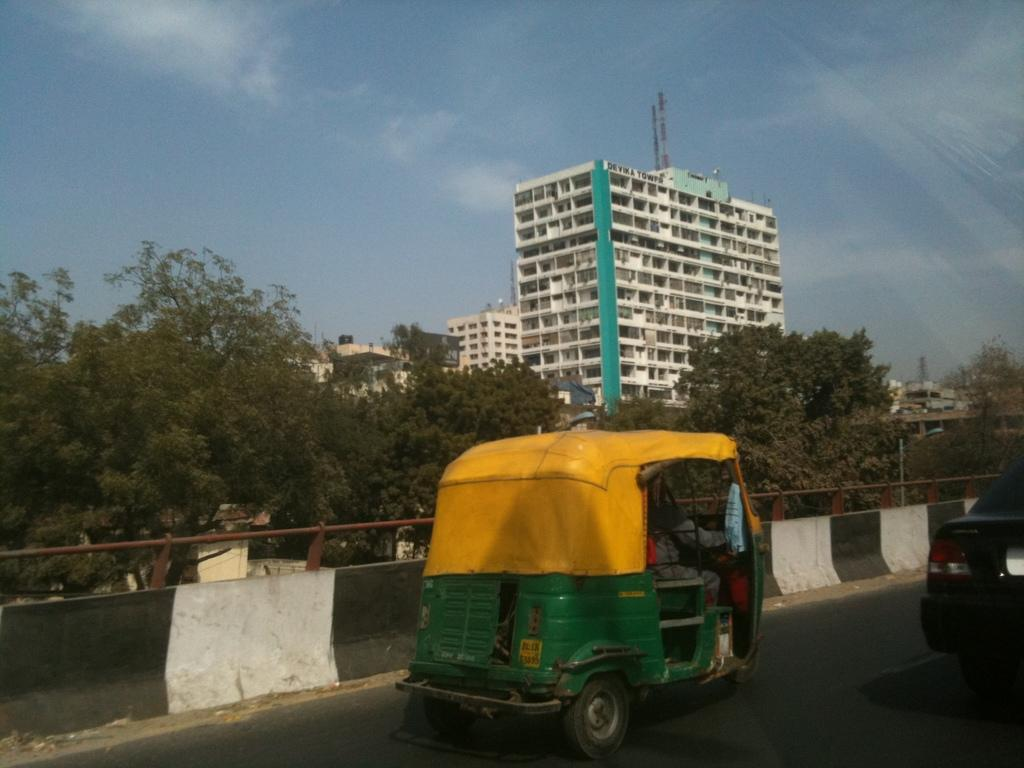What is happening on the road in the image? There are vehicles on the road in the image. What can be seen in the background of the image? There are trees, buildings, and a tower in the background of the image. What is visible in the sky in the image? The sky is visible in the background of the image, and clouds are present. What type of beef is being served at the selection in the image? There is no mention of beef or a selection in the image; it features vehicles on the road and various elements in the background. 